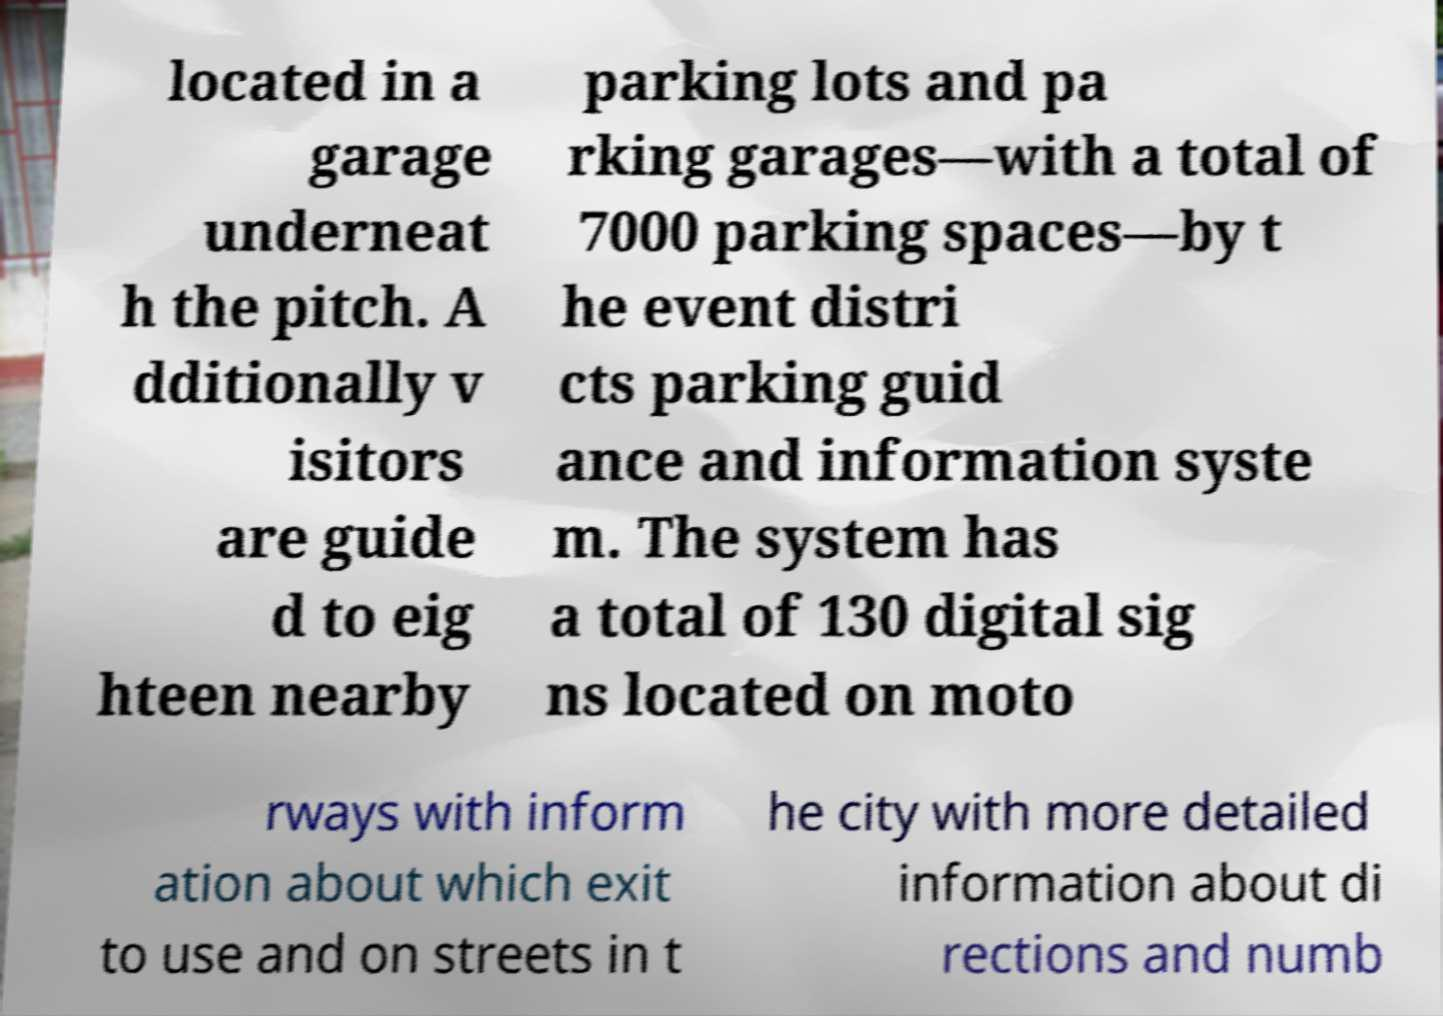Where might these parking directions be applicable? Given the description of numerous parking lots, garages, and a detailed guidance system with digital signs on motorways and city streets, these parking directions likely apply to a large venue or event district capable of hosting thousands of visitors. Such venues often include sports stadiums, convention centers, or large entertainment complexes. 